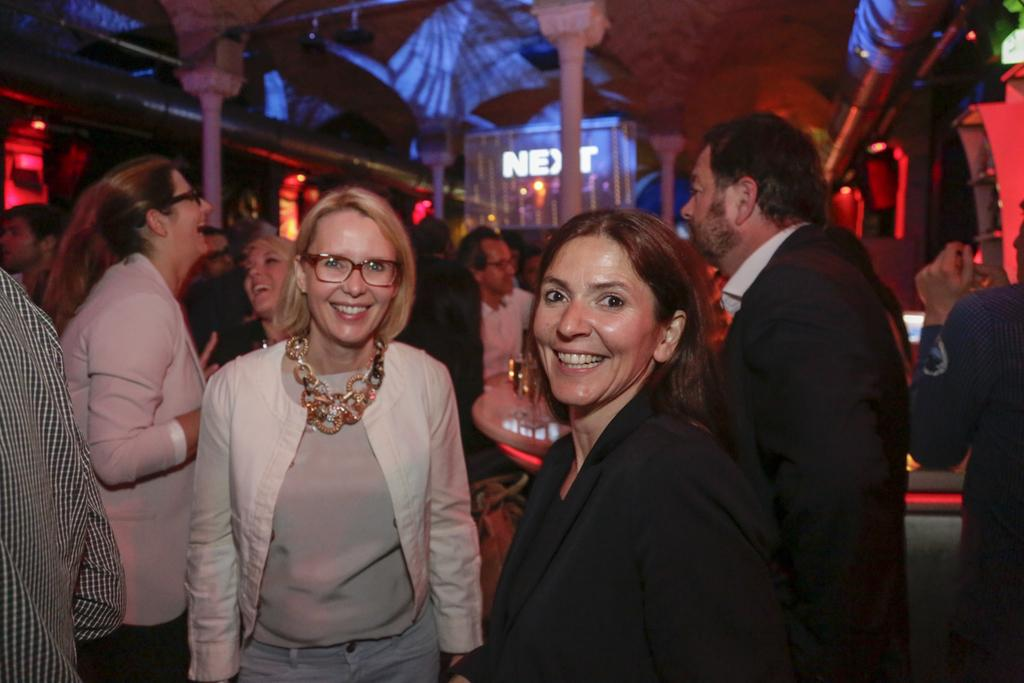What is happening on the floor in the image? There are persons in different color dresses on a floor. What is the facial expression of some of the persons? Some of the persons are smiling. What can be seen in the background of the image? There is a hoarding, pillars, lights, and a roof visible in the background. What type of turkey can be seen in the image? There is no turkey present in the image; it features persons on a floor and background elements. How does the love between the persons manifest in the image? The image does not depict any romantic relationships or emotions, so it is not possible to determine how love might manifest between the persons. 